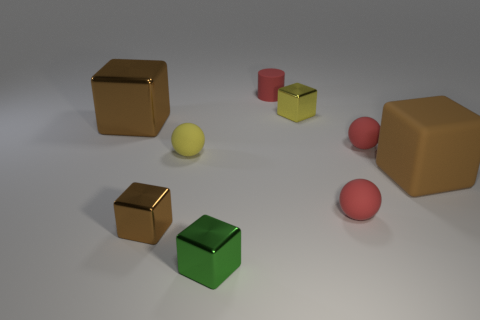Do the red cylinder and the shiny block that is to the right of the green thing have the same size?
Give a very brief answer. Yes. What number of big things are either yellow rubber balls or matte blocks?
Your answer should be compact. 1. Are there more brown matte cylinders than green blocks?
Your answer should be very brief. No. There is a rubber object that is on the left side of the small rubber object that is behind the yellow block; what number of tiny matte balls are behind it?
Give a very brief answer. 1. What is the shape of the big matte thing?
Provide a succinct answer. Cube. How many other objects are there of the same material as the green cube?
Provide a short and direct response. 3. Do the yellow cube and the green thing have the same size?
Provide a succinct answer. Yes. What shape is the large thing that is to the left of the tiny green thing?
Make the answer very short. Cube. There is a small rubber sphere that is in front of the ball on the left side of the yellow shiny object; what is its color?
Provide a succinct answer. Red. There is a tiny rubber thing that is behind the yellow metallic thing; does it have the same shape as the shiny object that is right of the green metal thing?
Keep it short and to the point. No. 